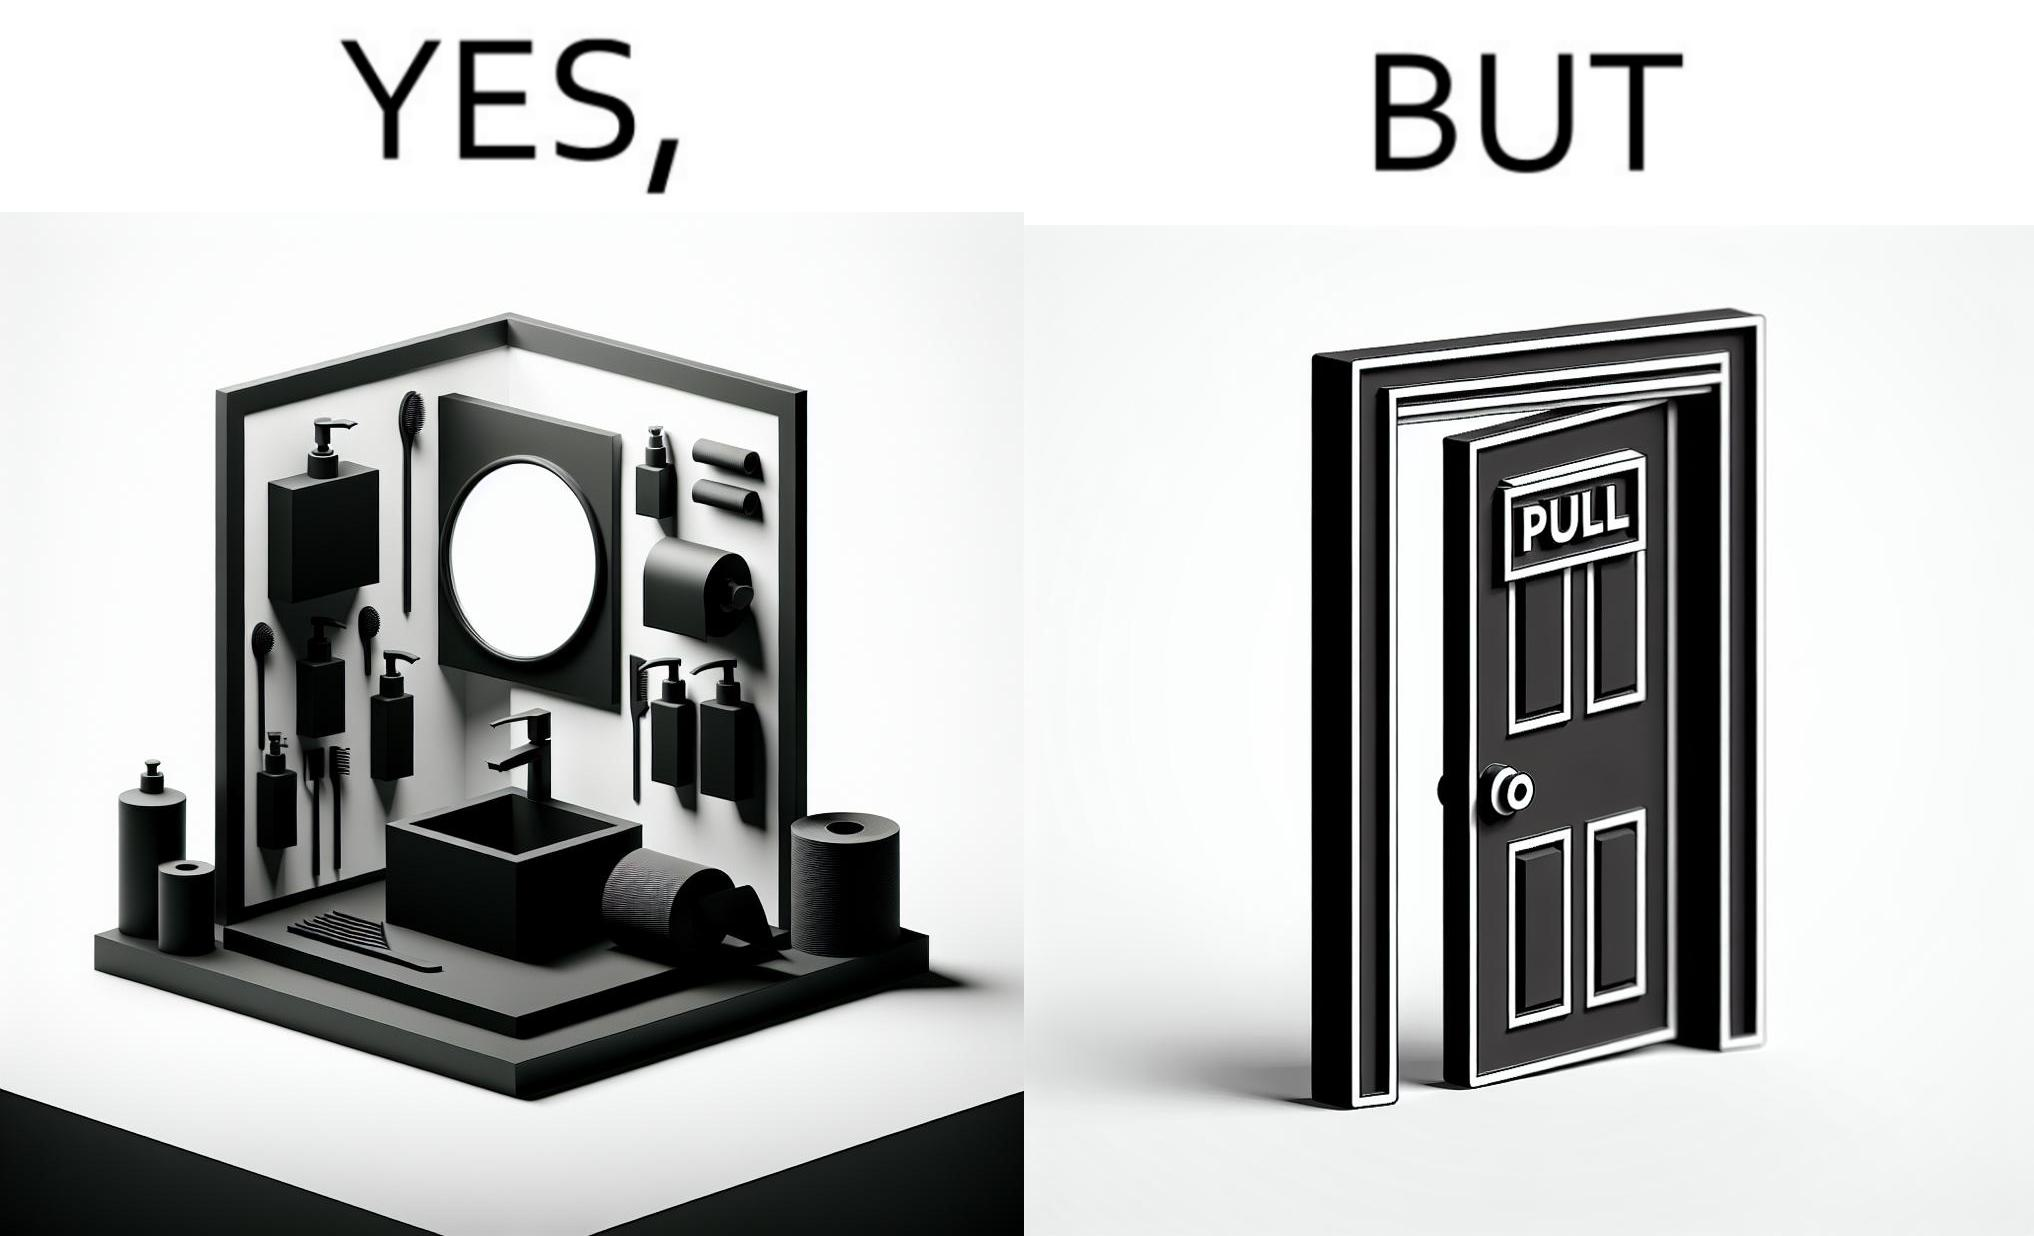Is this a satirical image? Yes, this image is satirical. 